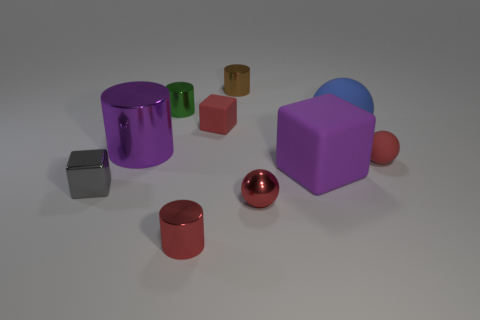Subtract all blue cylinders. Subtract all gray cubes. How many cylinders are left? 4 Subtract all spheres. How many objects are left? 7 Subtract all tiny red metal things. Subtract all tiny brown objects. How many objects are left? 7 Add 3 small objects. How many small objects are left? 10 Add 3 red cylinders. How many red cylinders exist? 4 Subtract 0 green blocks. How many objects are left? 10 